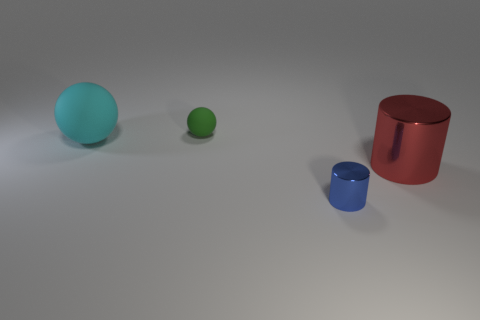Do the tiny thing in front of the large cyan object and the big object that is left of the large red cylinder have the same shape?
Your response must be concise. No. Is the number of green matte spheres on the left side of the cyan object less than the number of large red cylinders to the right of the tiny green matte sphere?
Your answer should be compact. Yes. How many other things are there of the same shape as the cyan thing?
Provide a short and direct response. 1. There is a large red object that is the same material as the blue cylinder; what is its shape?
Your answer should be very brief. Cylinder. What color is the thing that is both in front of the large matte sphere and behind the blue thing?
Ensure brevity in your answer.  Red. Is the big thing left of the tiny metal cylinder made of the same material as the red thing?
Your response must be concise. No. Is the number of tiny cylinders behind the blue metal thing less than the number of small rubber objects?
Offer a terse response. Yes. Is there a yellow cylinder made of the same material as the blue thing?
Offer a terse response. No. Is the size of the red metallic cylinder the same as the matte thing that is in front of the small rubber sphere?
Offer a terse response. Yes. Is there a tiny thing of the same color as the large matte thing?
Give a very brief answer. No. 